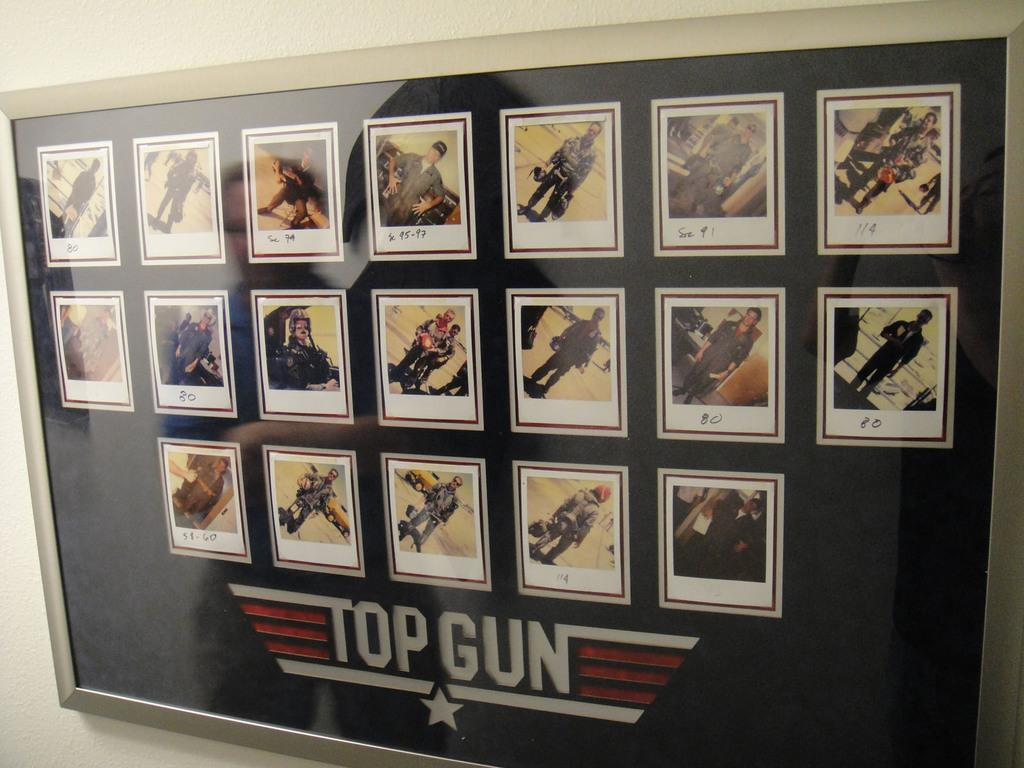<image>
Summarize the visual content of the image. A framed poster of the cast of the movie Top Gun. 